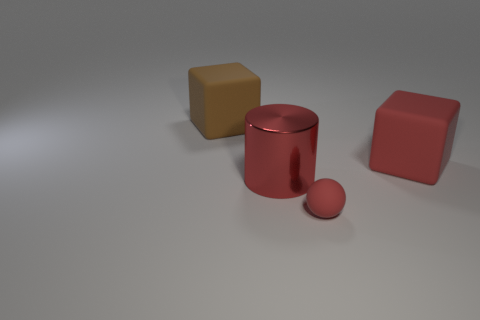There is a small object that is the same color as the cylinder; what is its shape?
Keep it short and to the point. Sphere. Does the rubber block that is on the left side of the large red block have the same color as the matte thing that is in front of the red matte cube?
Offer a very short reply. No. There is a cube that is the same color as the metallic cylinder; what size is it?
Offer a terse response. Large. What number of other things are the same size as the red block?
Your answer should be compact. 2. There is a big cube in front of the big brown matte block; what is its color?
Provide a short and direct response. Red. Does the red object in front of the large metal cylinder have the same material as the large cylinder?
Your answer should be very brief. No. How many red rubber objects are both in front of the red cylinder and right of the red matte sphere?
Ensure brevity in your answer.  0. What is the color of the large matte block on the left side of the red matte object that is to the left of the big block right of the big brown rubber cube?
Your answer should be compact. Brown. What number of other objects are there of the same shape as the small object?
Make the answer very short. 0. There is a block right of the small red matte thing; are there any large red rubber objects on the left side of it?
Offer a very short reply. No. 